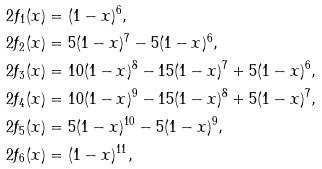Convert formula to latex. <formula><loc_0><loc_0><loc_500><loc_500>2 f _ { 1 } ( x ) & = ( 1 - x ) ^ { 6 } , \\ 2 f _ { 2 } ( x ) & = 5 ( 1 - x ) ^ { 7 } - 5 ( 1 - x ) ^ { 6 } , \\ 2 f _ { 3 } ( x ) & = 1 0 ( 1 - x ) ^ { 8 } - 1 5 ( 1 - x ) ^ { 7 } + 5 ( 1 - x ) ^ { 6 } , \\ 2 f _ { 4 } ( x ) & = 1 0 ( 1 - x ) ^ { 9 } - 1 5 ( 1 - x ) ^ { 8 } + 5 ( 1 - x ) ^ { 7 } , \\ 2 f _ { 5 } ( x ) & = 5 ( 1 - x ) ^ { 1 0 } - 5 ( 1 - x ) ^ { 9 } , \\ 2 f _ { 6 } ( x ) & = ( 1 - x ) ^ { 1 1 } ,</formula> 